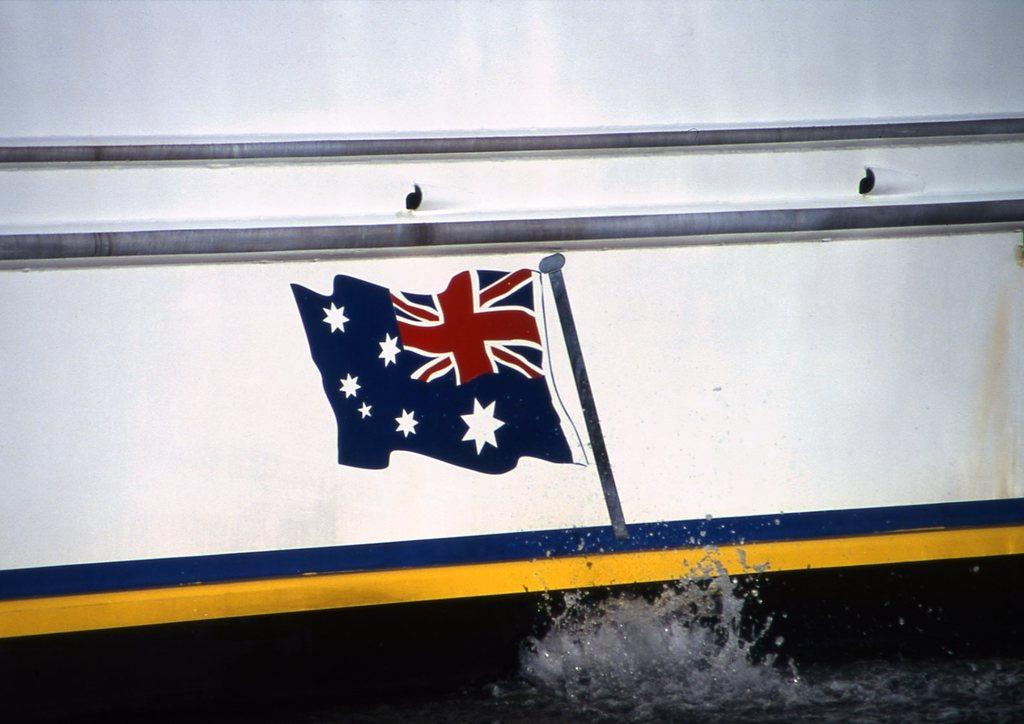Describe this image in one or two sentences. In this image I can see some part of boat, on which flag poles, flag, metal rods, at the bottom there is water visible. 